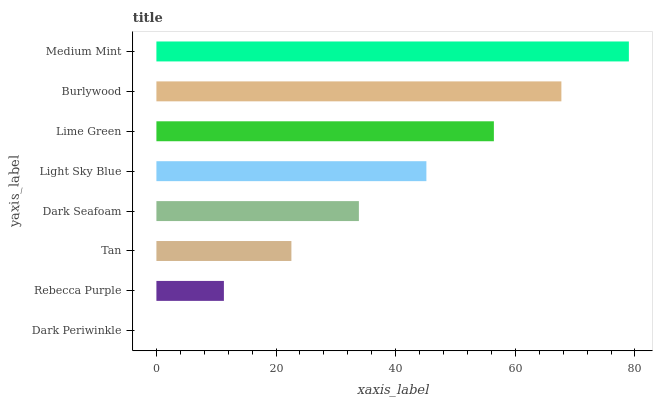Is Dark Periwinkle the minimum?
Answer yes or no. Yes. Is Medium Mint the maximum?
Answer yes or no. Yes. Is Rebecca Purple the minimum?
Answer yes or no. No. Is Rebecca Purple the maximum?
Answer yes or no. No. Is Rebecca Purple greater than Dark Periwinkle?
Answer yes or no. Yes. Is Dark Periwinkle less than Rebecca Purple?
Answer yes or no. Yes. Is Dark Periwinkle greater than Rebecca Purple?
Answer yes or no. No. Is Rebecca Purple less than Dark Periwinkle?
Answer yes or no. No. Is Light Sky Blue the high median?
Answer yes or no. Yes. Is Dark Seafoam the low median?
Answer yes or no. Yes. Is Rebecca Purple the high median?
Answer yes or no. No. Is Light Sky Blue the low median?
Answer yes or no. No. 